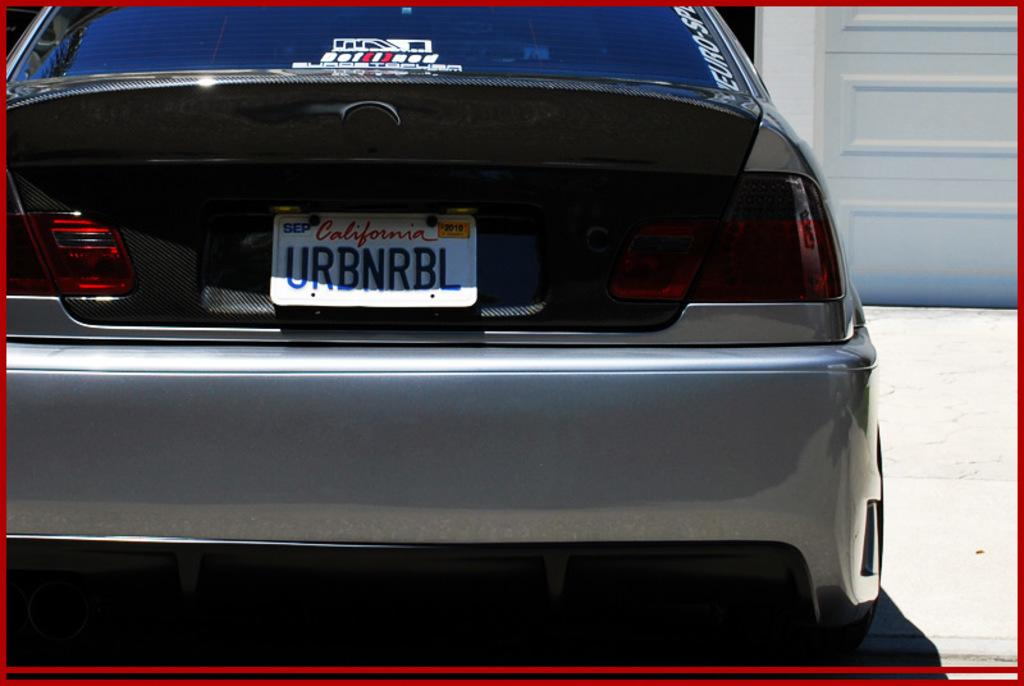<image>
Create a compact narrative representing the image presented. A light gray sports car with a licence plate from California. 